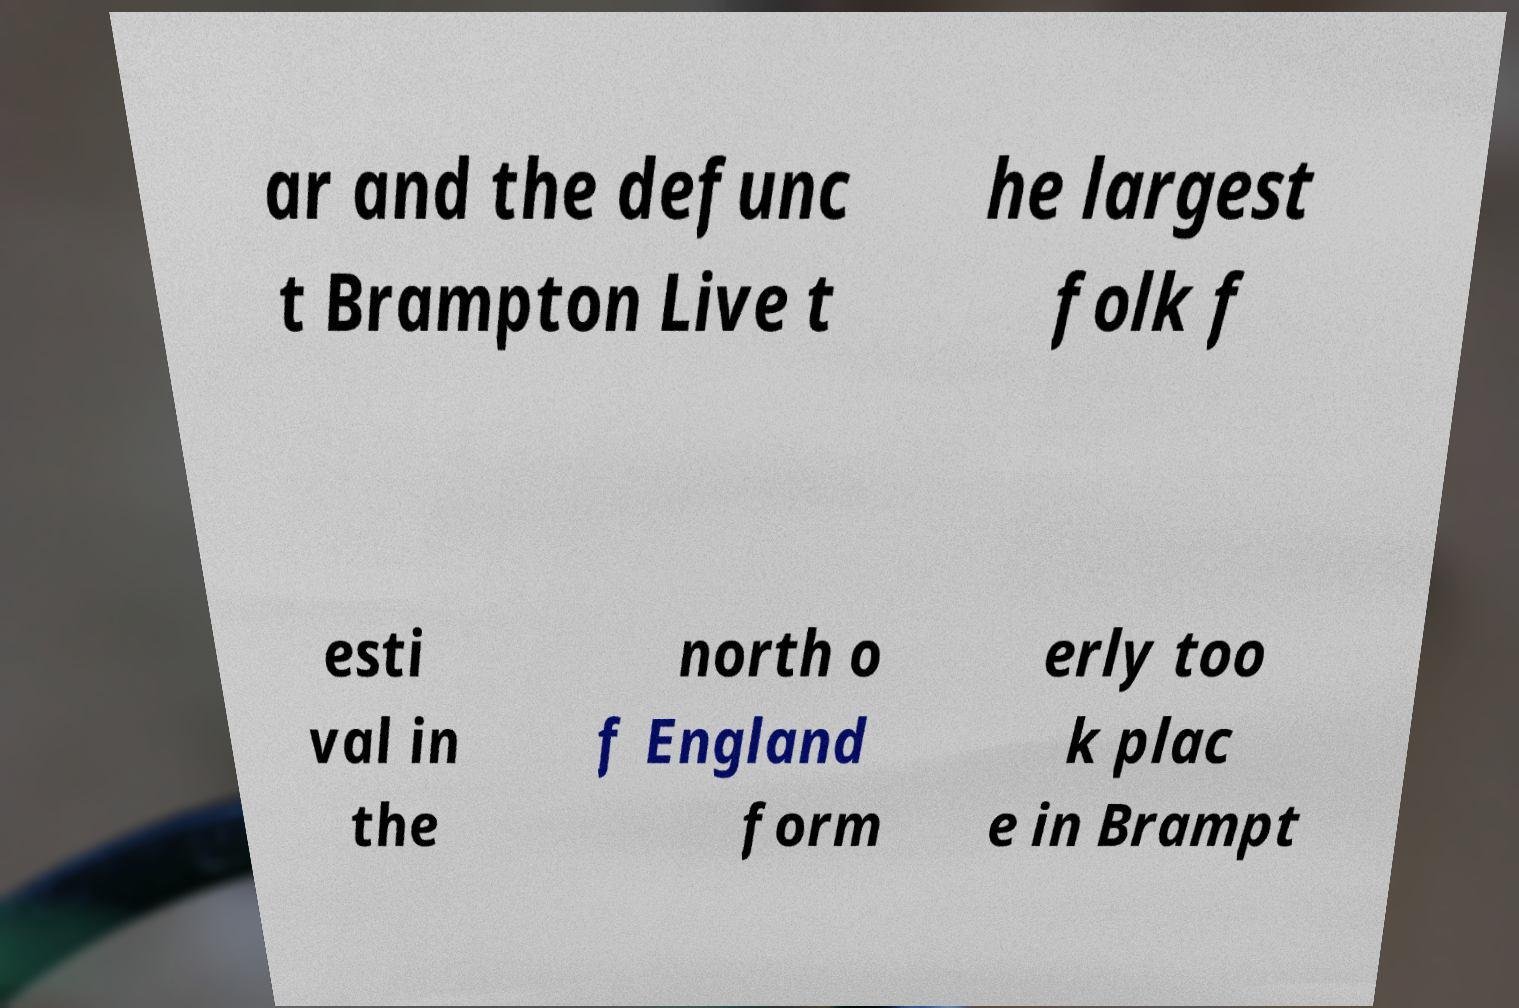Can you read and provide the text displayed in the image?This photo seems to have some interesting text. Can you extract and type it out for me? ar and the defunc t Brampton Live t he largest folk f esti val in the north o f England form erly too k plac e in Brampt 